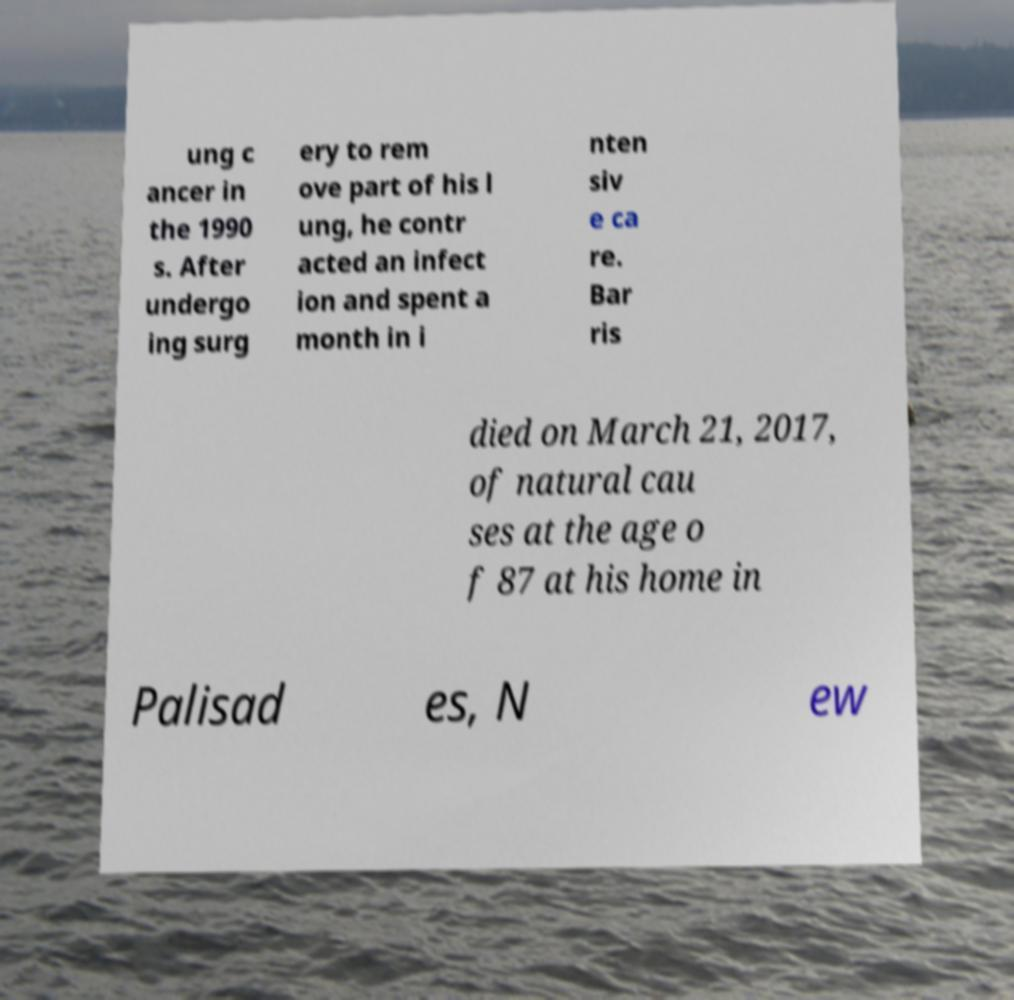Can you read and provide the text displayed in the image?This photo seems to have some interesting text. Can you extract and type it out for me? ung c ancer in the 1990 s. After undergo ing surg ery to rem ove part of his l ung, he contr acted an infect ion and spent a month in i nten siv e ca re. Bar ris died on March 21, 2017, of natural cau ses at the age o f 87 at his home in Palisad es, N ew 